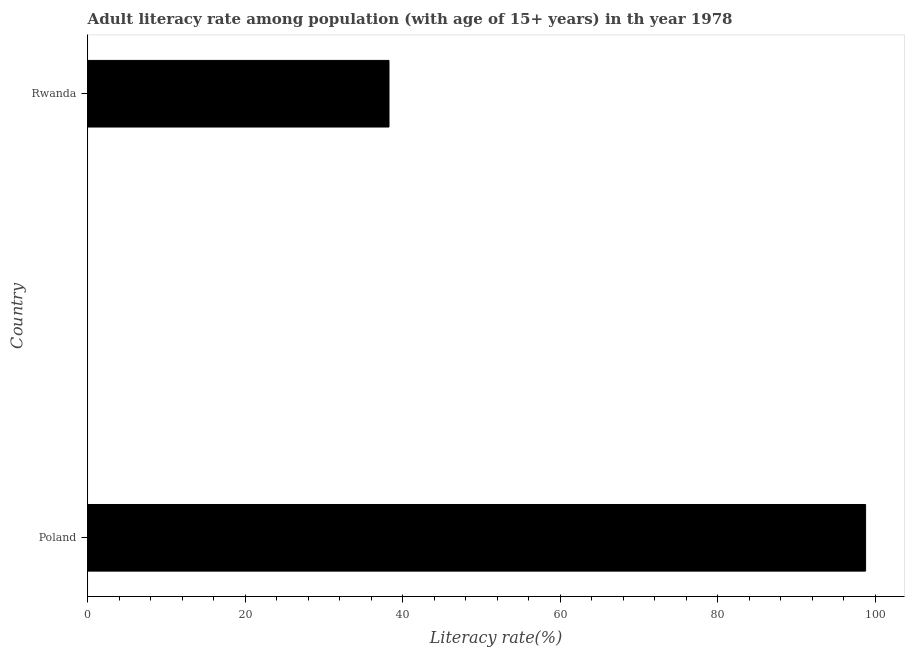What is the title of the graph?
Offer a terse response. Adult literacy rate among population (with age of 15+ years) in th year 1978. What is the label or title of the X-axis?
Offer a terse response. Literacy rate(%). What is the adult literacy rate in Poland?
Provide a short and direct response. 98.74. Across all countries, what is the maximum adult literacy rate?
Give a very brief answer. 98.74. Across all countries, what is the minimum adult literacy rate?
Give a very brief answer. 38.24. In which country was the adult literacy rate minimum?
Give a very brief answer. Rwanda. What is the sum of the adult literacy rate?
Offer a very short reply. 136.99. What is the difference between the adult literacy rate in Poland and Rwanda?
Offer a very short reply. 60.5. What is the average adult literacy rate per country?
Give a very brief answer. 68.49. What is the median adult literacy rate?
Make the answer very short. 68.49. In how many countries, is the adult literacy rate greater than 80 %?
Provide a succinct answer. 1. What is the ratio of the adult literacy rate in Poland to that in Rwanda?
Provide a succinct answer. 2.58. Is the adult literacy rate in Poland less than that in Rwanda?
Provide a succinct answer. No. How many bars are there?
Offer a terse response. 2. Are the values on the major ticks of X-axis written in scientific E-notation?
Your answer should be very brief. No. What is the Literacy rate(%) in Poland?
Offer a very short reply. 98.74. What is the Literacy rate(%) in Rwanda?
Provide a short and direct response. 38.24. What is the difference between the Literacy rate(%) in Poland and Rwanda?
Make the answer very short. 60.5. What is the ratio of the Literacy rate(%) in Poland to that in Rwanda?
Keep it short and to the point. 2.58. 